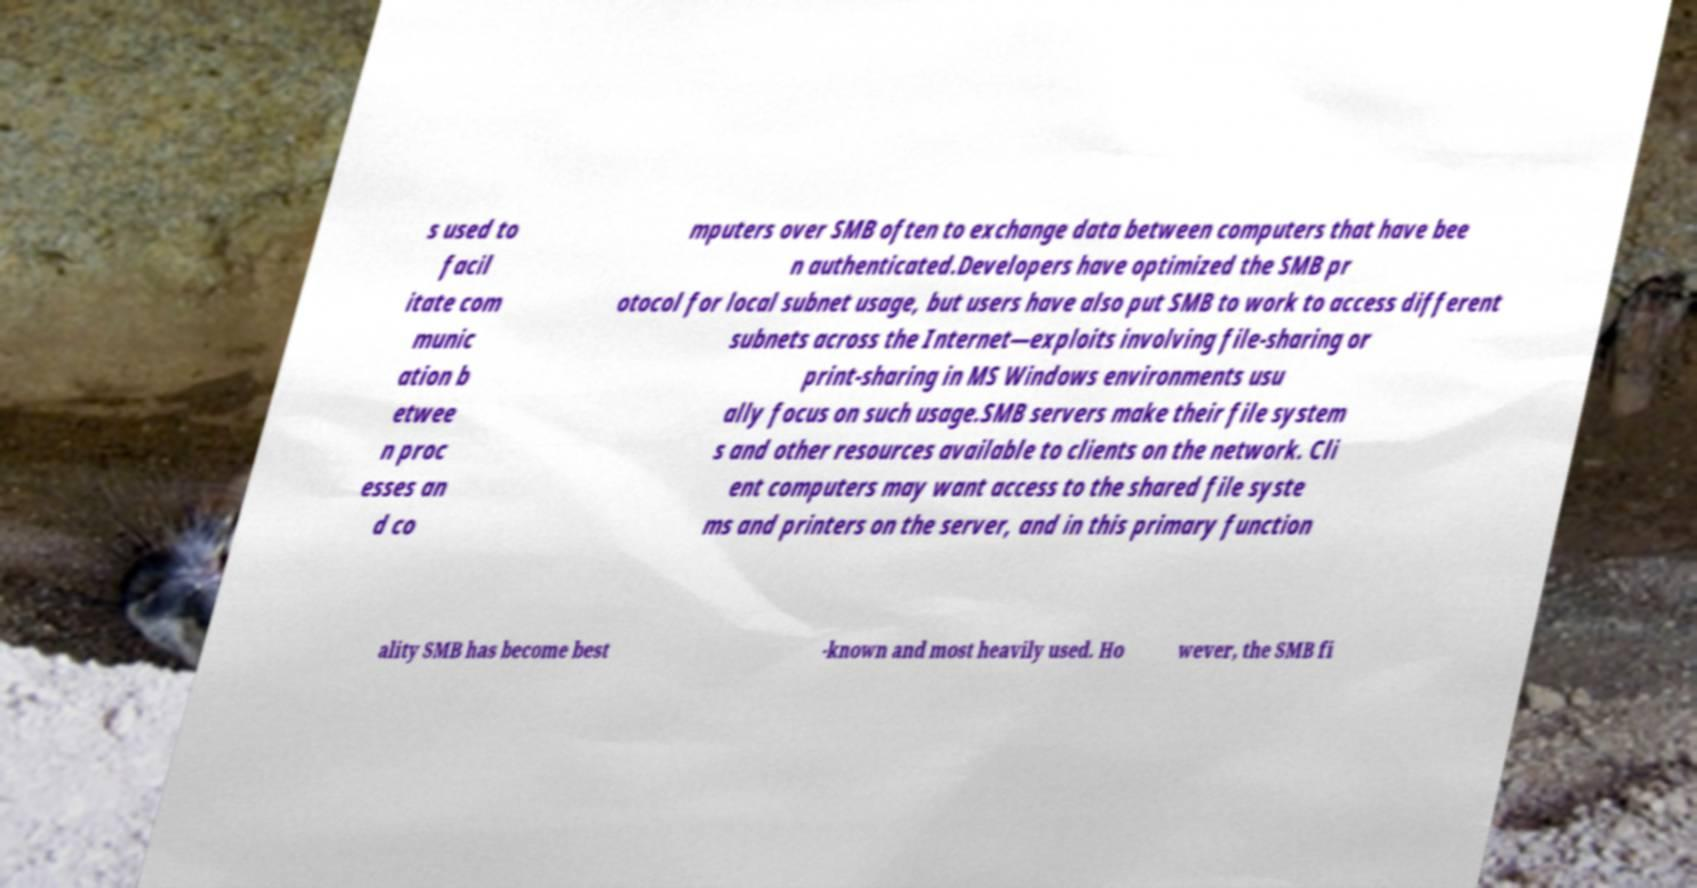For documentation purposes, I need the text within this image transcribed. Could you provide that? s used to facil itate com munic ation b etwee n proc esses an d co mputers over SMB often to exchange data between computers that have bee n authenticated.Developers have optimized the SMB pr otocol for local subnet usage, but users have also put SMB to work to access different subnets across the Internet—exploits involving file-sharing or print-sharing in MS Windows environments usu ally focus on such usage.SMB servers make their file system s and other resources available to clients on the network. Cli ent computers may want access to the shared file syste ms and printers on the server, and in this primary function ality SMB has become best -known and most heavily used. Ho wever, the SMB fi 